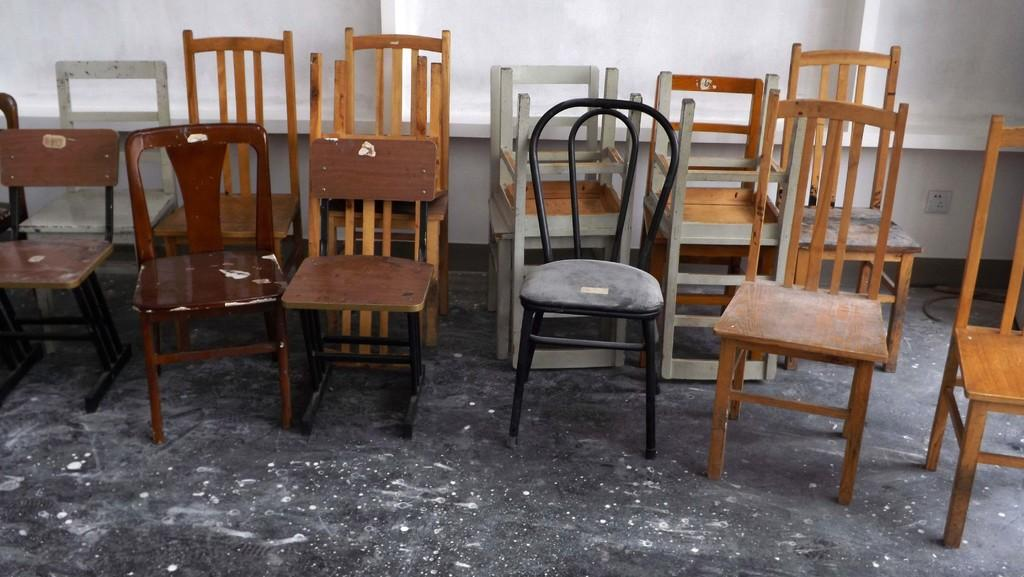What material are the chairs in the image made of? The chairs in the image are made of wood. Where are the chairs located in the image? The chairs are on the floor. What can be seen in the background of the image? There is a wall visible in the background of the image. What is the rate at which the pear is being consumed in the image? There is no pear present in the image, so it is not possible to determine a rate of consumption. 